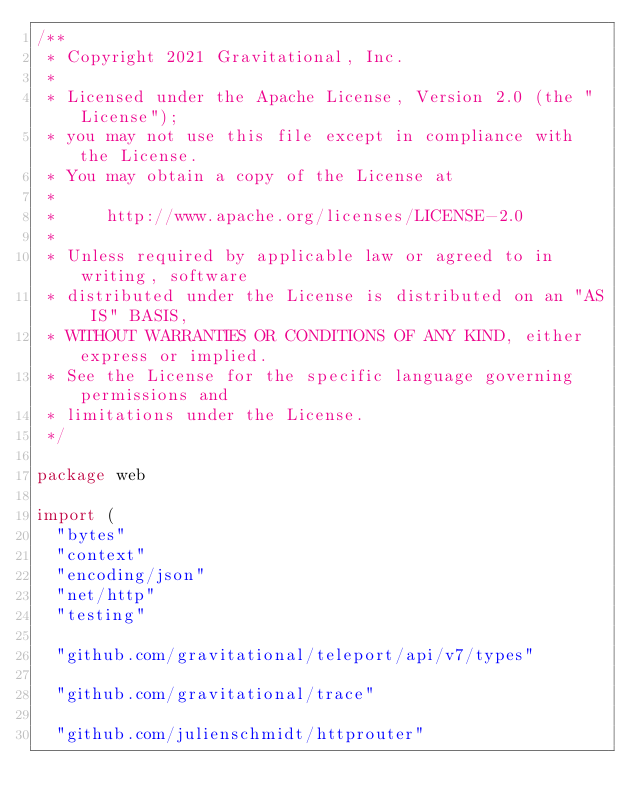<code> <loc_0><loc_0><loc_500><loc_500><_Go_>/**
 * Copyright 2021 Gravitational, Inc.
 *
 * Licensed under the Apache License, Version 2.0 (the "License");
 * you may not use this file except in compliance with the License.
 * You may obtain a copy of the License at
 *
 *     http://www.apache.org/licenses/LICENSE-2.0
 *
 * Unless required by applicable law or agreed to in writing, software
 * distributed under the License is distributed on an "AS IS" BASIS,
 * WITHOUT WARRANTIES OR CONDITIONS OF ANY KIND, either express or implied.
 * See the License for the specific language governing permissions and
 * limitations under the License.
 */

package web

import (
	"bytes"
	"context"
	"encoding/json"
	"net/http"
	"testing"

	"github.com/gravitational/teleport/api/v7/types"

	"github.com/gravitational/trace"

	"github.com/julienschmidt/httprouter"</code> 